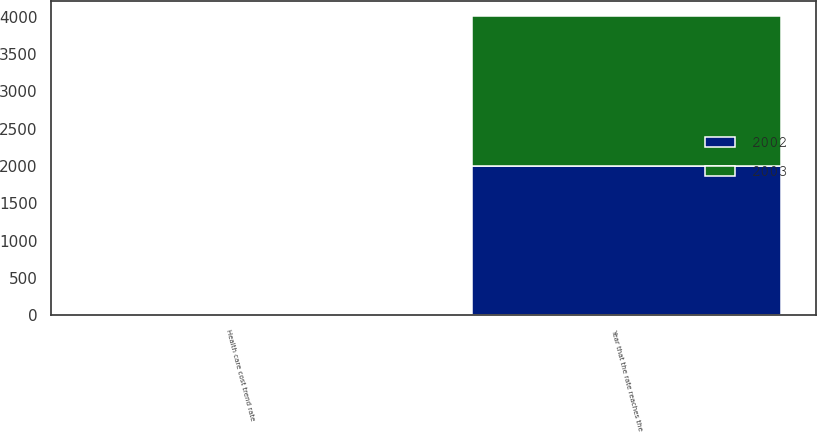<chart> <loc_0><loc_0><loc_500><loc_500><stacked_bar_chart><ecel><fcel>Health care cost trend rate<fcel>Year that the rate reaches the<nl><fcel>2003<fcel>9<fcel>2009<nl><fcel>2002<fcel>7<fcel>2004<nl></chart> 